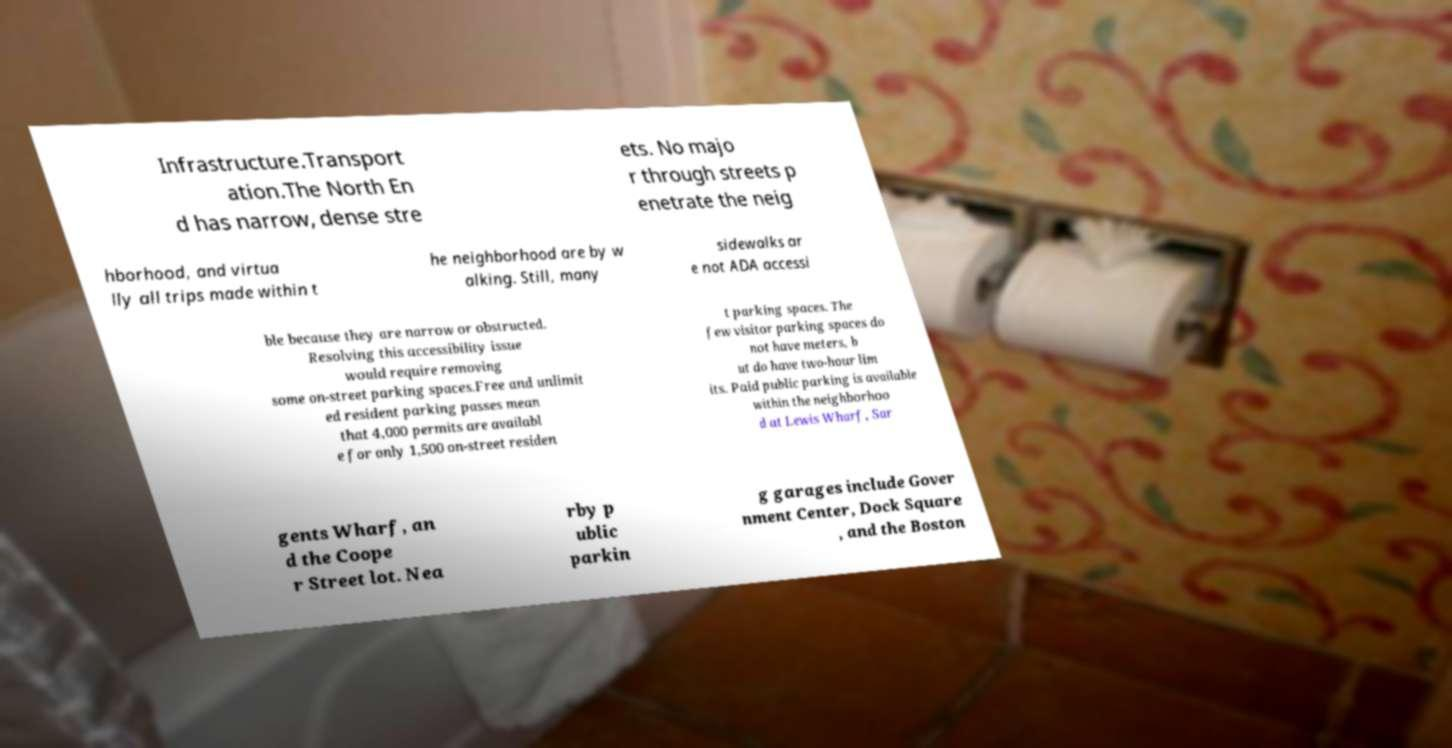There's text embedded in this image that I need extracted. Can you transcribe it verbatim? Infrastructure.Transport ation.The North En d has narrow, dense stre ets. No majo r through streets p enetrate the neig hborhood, and virtua lly all trips made within t he neighborhood are by w alking. Still, many sidewalks ar e not ADA accessi ble because they are narrow or obstructed. Resolving this accessibility issue would require removing some on-street parking spaces.Free and unlimit ed resident parking passes mean that 4,000 permits are availabl e for only 1,500 on-street residen t parking spaces. The few visitor parking spaces do not have meters, b ut do have two-hour lim its. Paid public parking is available within the neighborhoo d at Lewis Wharf, Sar gents Wharf, an d the Coope r Street lot. Nea rby p ublic parkin g garages include Gover nment Center, Dock Square , and the Boston 